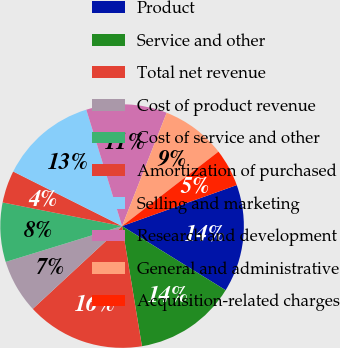<chart> <loc_0><loc_0><loc_500><loc_500><pie_chart><fcel>Product<fcel>Service and other<fcel>Total net revenue<fcel>Cost of product revenue<fcel>Cost of service and other<fcel>Amortization of purchased<fcel>Selling and marketing<fcel>Research and development<fcel>General and administrative<fcel>Acquisition-related charges<nl><fcel>14.29%<fcel>13.57%<fcel>15.71%<fcel>7.14%<fcel>7.86%<fcel>4.29%<fcel>12.86%<fcel>10.71%<fcel>8.57%<fcel>5.0%<nl></chart> 